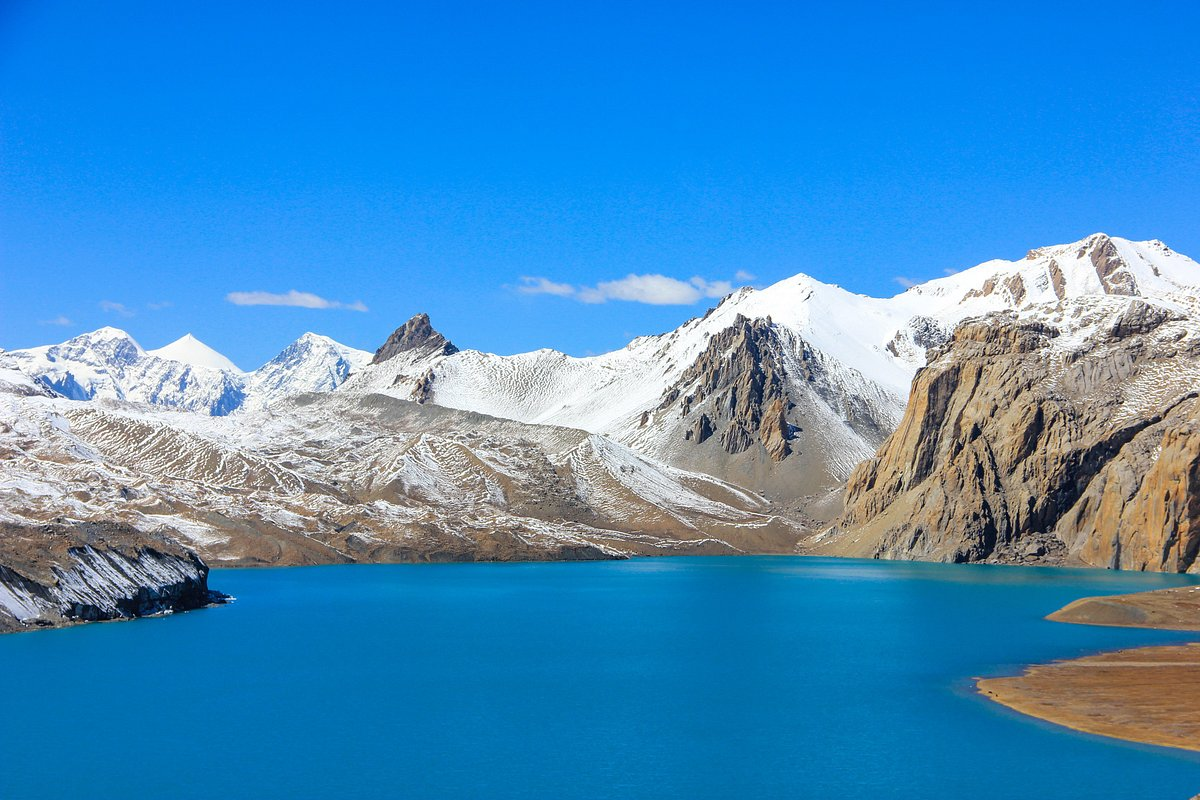What do you see happening in this image? This image reveals a tranquil high-altitude glacial lake cradled amidst rugged mountains, which are capped with snow, suggesting a pristine, remote environment. The bright blue lake is likely fed by glacial meltwaters, as indicated by its vibrant color and clarity. The crisp blue sky above mirrors the lake's hue, enhancing the tranquility of the scene. The barren slopes around the lake imply a sparse vegetation zone, often found in high mountain ranges. The untouched nature of the landscape invites contemplation and highlights the diverse beauty found in such remote parts of the world. 